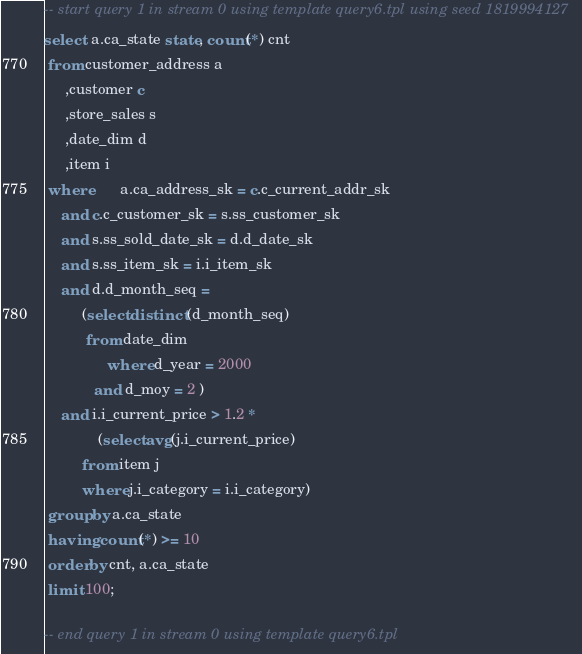Convert code to text. <code><loc_0><loc_0><loc_500><loc_500><_SQL_>-- start query 1 in stream 0 using template query6.tpl using seed 1819994127
select  a.ca_state state, count(*) cnt
 from customer_address a
     ,customer c
     ,store_sales s
     ,date_dim d
     ,item i
 where       a.ca_address_sk = c.c_current_addr_sk
 	and c.c_customer_sk = s.ss_customer_sk
 	and s.ss_sold_date_sk = d.d_date_sk
 	and s.ss_item_sk = i.i_item_sk
 	and d.d_month_seq = 
 	     (select distinct (d_month_seq)
 	      from date_dim
               where d_year = 2000
 	        and d_moy = 2 )
 	and i.i_current_price > 1.2 * 
             (select avg(j.i_current_price) 
 	     from item j 
 	     where j.i_category = i.i_category)
 group by a.ca_state
 having count(*) >= 10
 order by cnt, a.ca_state 
 limit 100;

-- end query 1 in stream 0 using template query6.tpl
</code> 